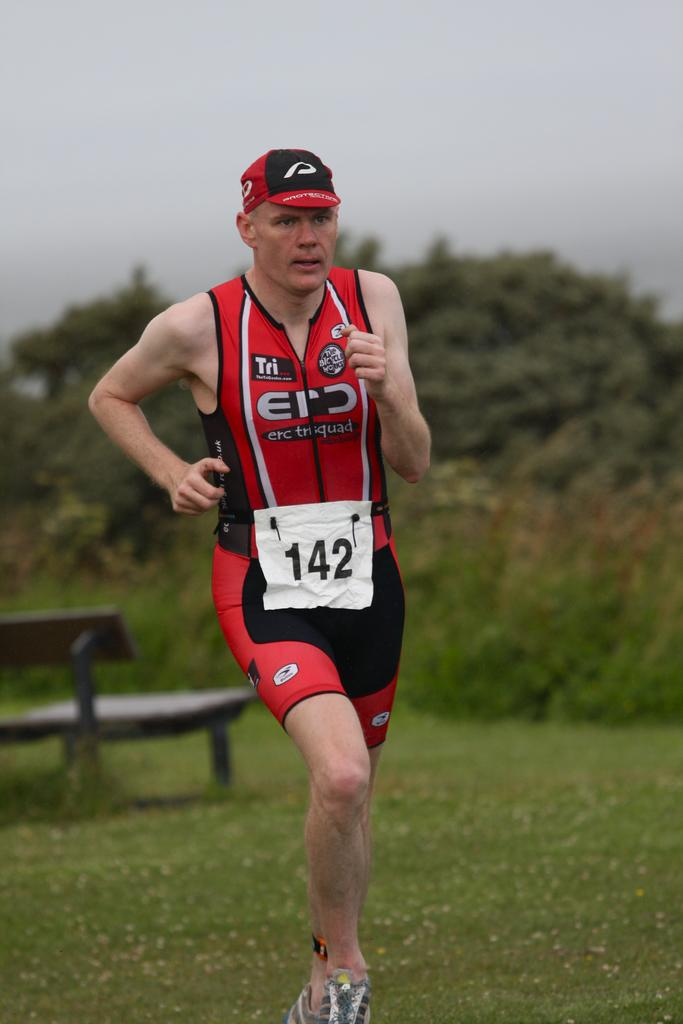<image>
Create a compact narrative representing the image presented. A runner waering the number 142 wears a red top sponsored by ERC 